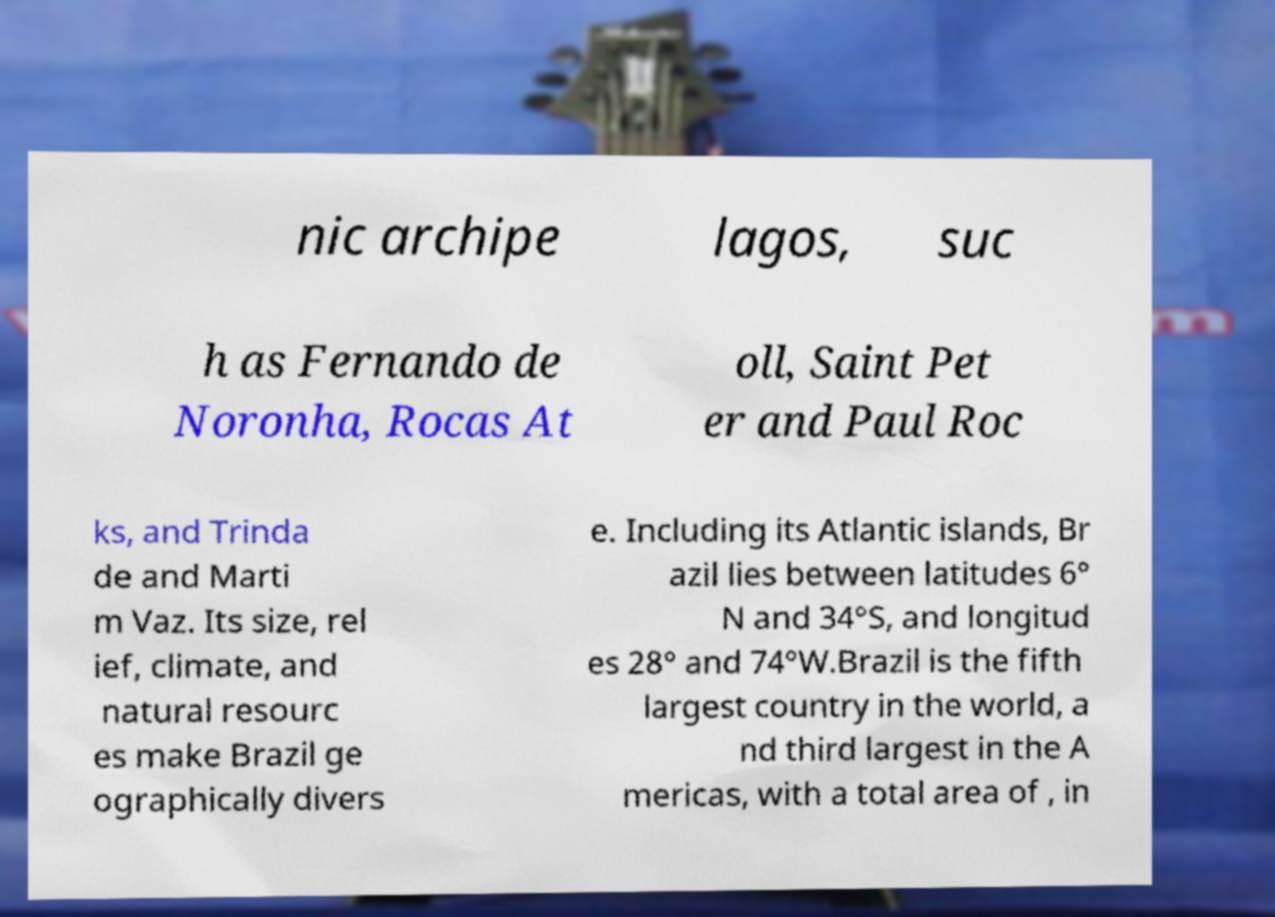Could you assist in decoding the text presented in this image and type it out clearly? nic archipe lagos, suc h as Fernando de Noronha, Rocas At oll, Saint Pet er and Paul Roc ks, and Trinda de and Marti m Vaz. Its size, rel ief, climate, and natural resourc es make Brazil ge ographically divers e. Including its Atlantic islands, Br azil lies between latitudes 6° N and 34°S, and longitud es 28° and 74°W.Brazil is the fifth largest country in the world, a nd third largest in the A mericas, with a total area of , in 